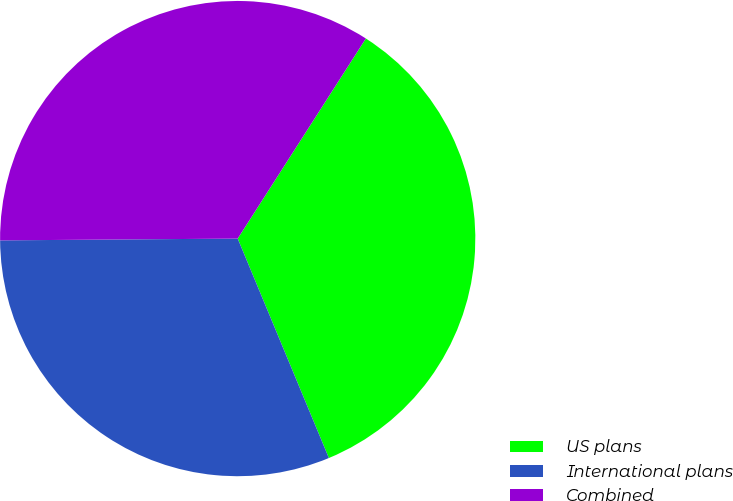Convert chart. <chart><loc_0><loc_0><loc_500><loc_500><pie_chart><fcel>US plans<fcel>International plans<fcel>Combined<nl><fcel>34.67%<fcel>31.15%<fcel>34.19%<nl></chart> 